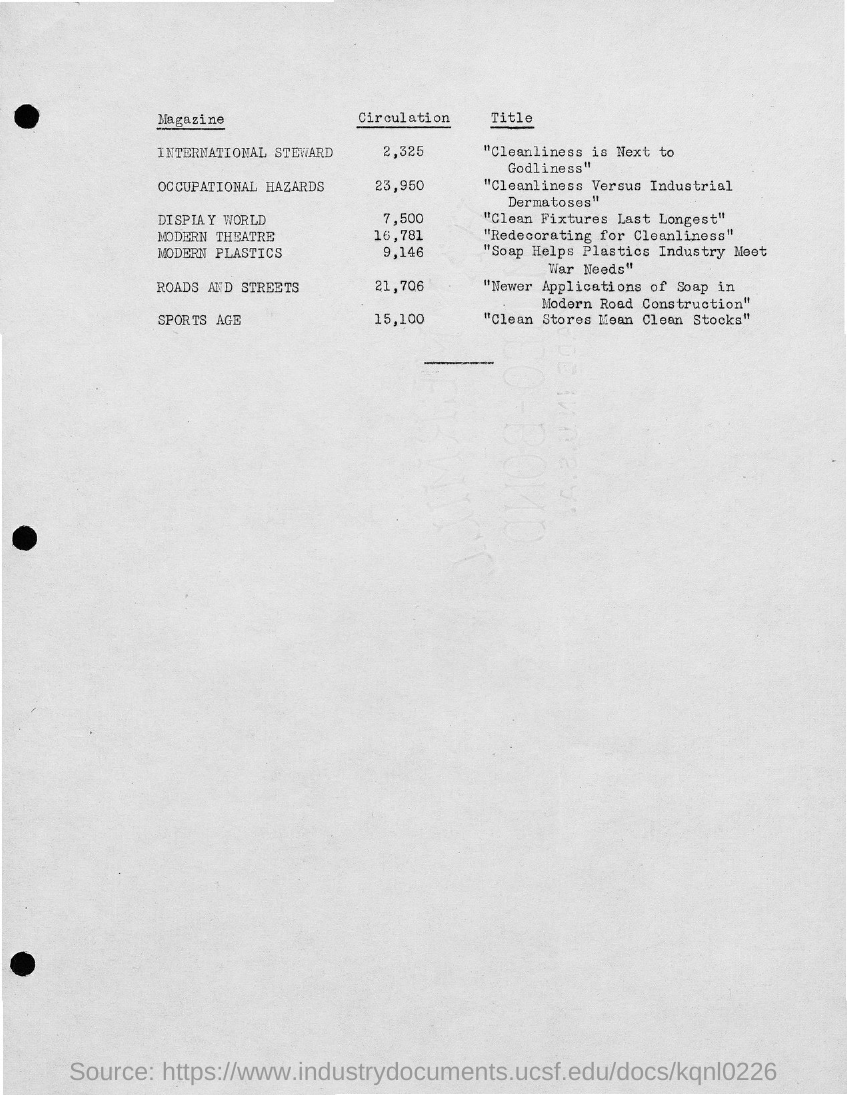Name of the magazine with circulation 15,100?
Your answer should be very brief. SPORTS AGE. Name of the magazine with circulation 21,706?
Offer a very short reply. Roads and streets. 